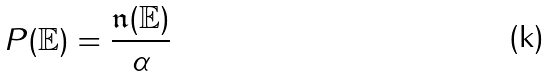Convert formula to latex. <formula><loc_0><loc_0><loc_500><loc_500>P ( \mathbb { E } ) = \frac { \mathfrak { n } ( \mathbb { E } ) } { \alpha }</formula> 